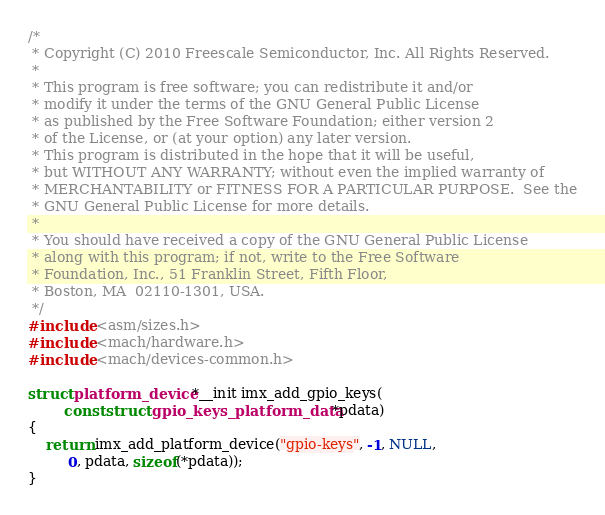Convert code to text. <code><loc_0><loc_0><loc_500><loc_500><_C_>/*
 * Copyright (C) 2010 Freescale Semiconductor, Inc. All Rights Reserved.
 *
 * This program is free software; you can redistribute it and/or
 * modify it under the terms of the GNU General Public License
 * as published by the Free Software Foundation; either version 2
 * of the License, or (at your option) any later version.
 * This program is distributed in the hope that it will be useful,
 * but WITHOUT ANY WARRANTY; without even the implied warranty of
 * MERCHANTABILITY or FITNESS FOR A PARTICULAR PURPOSE.  See the
 * GNU General Public License for more details.
 *
 * You should have received a copy of the GNU General Public License
 * along with this program; if not, write to the Free Software
 * Foundation, Inc., 51 Franklin Street, Fifth Floor,
 * Boston, MA  02110-1301, USA.
 */
#include <asm/sizes.h>
#include <mach/hardware.h>
#include <mach/devices-common.h>

struct platform_device *__init imx_add_gpio_keys(
		const struct gpio_keys_platform_data *pdata)
{
	return imx_add_platform_device("gpio-keys", -1, NULL,
		 0, pdata, sizeof(*pdata));
}
</code> 